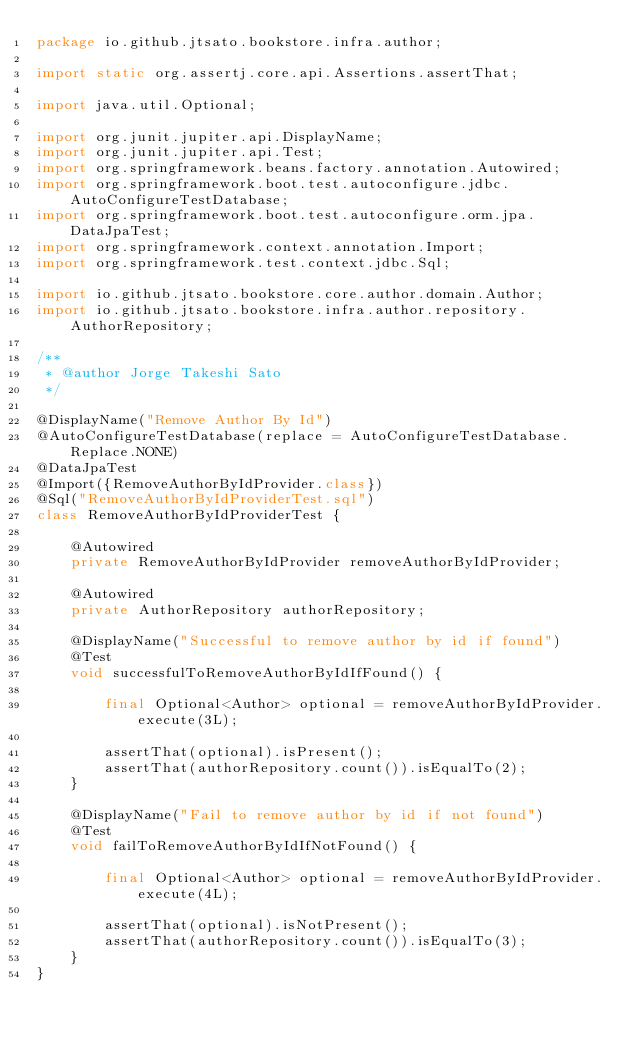Convert code to text. <code><loc_0><loc_0><loc_500><loc_500><_Java_>package io.github.jtsato.bookstore.infra.author;

import static org.assertj.core.api.Assertions.assertThat;

import java.util.Optional;

import org.junit.jupiter.api.DisplayName;
import org.junit.jupiter.api.Test;
import org.springframework.beans.factory.annotation.Autowired;
import org.springframework.boot.test.autoconfigure.jdbc.AutoConfigureTestDatabase;
import org.springframework.boot.test.autoconfigure.orm.jpa.DataJpaTest;
import org.springframework.context.annotation.Import;
import org.springframework.test.context.jdbc.Sql;

import io.github.jtsato.bookstore.core.author.domain.Author;
import io.github.jtsato.bookstore.infra.author.repository.AuthorRepository;

/**
 * @author Jorge Takeshi Sato
 */

@DisplayName("Remove Author By Id")
@AutoConfigureTestDatabase(replace = AutoConfigureTestDatabase.Replace.NONE)
@DataJpaTest
@Import({RemoveAuthorByIdProvider.class})
@Sql("RemoveAuthorByIdProviderTest.sql")
class RemoveAuthorByIdProviderTest {

    @Autowired
    private RemoveAuthorByIdProvider removeAuthorByIdProvider;

    @Autowired
    private AuthorRepository authorRepository;

    @DisplayName("Successful to remove author by id if found")
    @Test
    void successfulToRemoveAuthorByIdIfFound() {

        final Optional<Author> optional = removeAuthorByIdProvider.execute(3L);

        assertThat(optional).isPresent();
        assertThat(authorRepository.count()).isEqualTo(2);
    }

    @DisplayName("Fail to remove author by id if not found")
    @Test
    void failToRemoveAuthorByIdIfNotFound() {

        final Optional<Author> optional = removeAuthorByIdProvider.execute(4L);

        assertThat(optional).isNotPresent();
        assertThat(authorRepository.count()).isEqualTo(3);
    }
}
</code> 